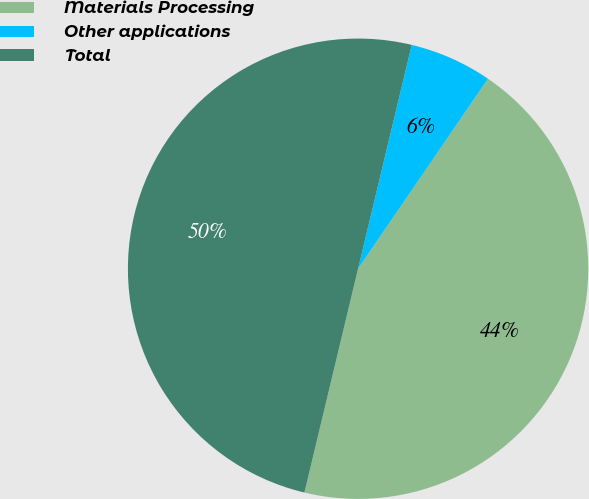<chart> <loc_0><loc_0><loc_500><loc_500><pie_chart><fcel>Materials Processing<fcel>Other applications<fcel>Total<nl><fcel>44.2%<fcel>5.8%<fcel>50.0%<nl></chart> 